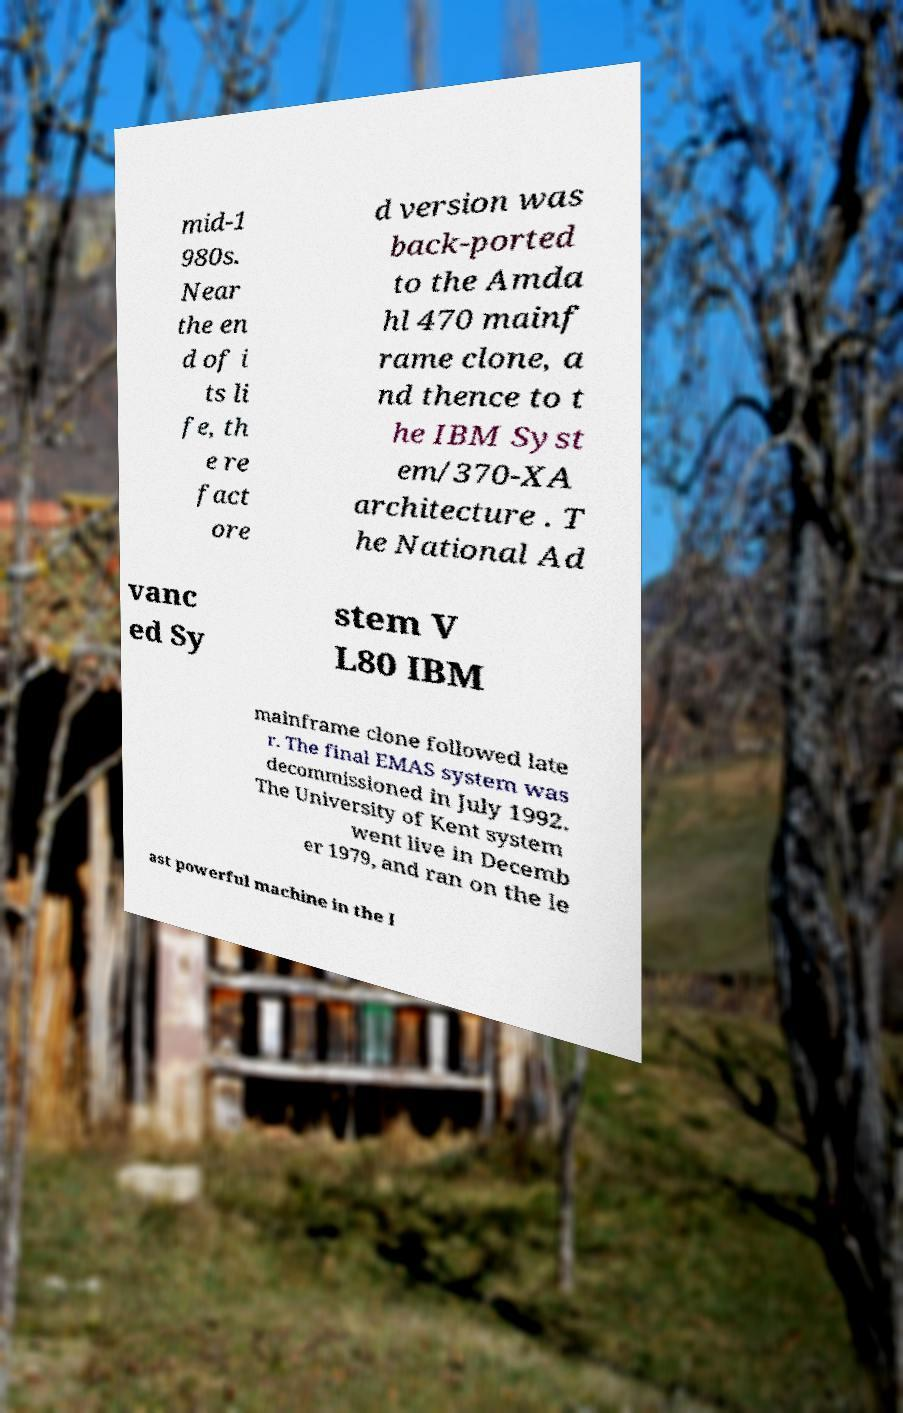I need the written content from this picture converted into text. Can you do that? mid-1 980s. Near the en d of i ts li fe, th e re fact ore d version was back-ported to the Amda hl 470 mainf rame clone, a nd thence to t he IBM Syst em/370-XA architecture . T he National Ad vanc ed Sy stem V L80 IBM mainframe clone followed late r. The final EMAS system was decommissioned in July 1992. The University of Kent system went live in Decemb er 1979, and ran on the le ast powerful machine in the I 